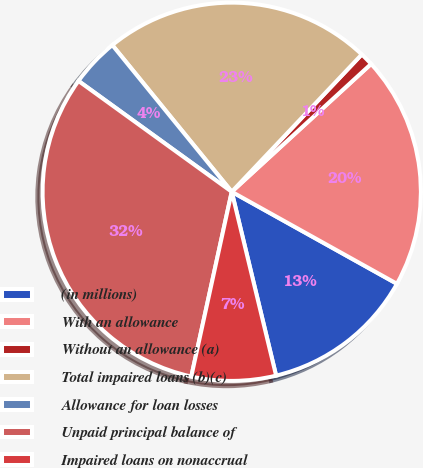<chart> <loc_0><loc_0><loc_500><loc_500><pie_chart><fcel>(in millions)<fcel>With an allowance<fcel>Without an allowance (a)<fcel>Total impaired loans (b)(c)<fcel>Allowance for loan losses<fcel>Unpaid principal balance of<fcel>Impaired loans on nonaccrual<nl><fcel>13.14%<fcel>19.9%<fcel>1.12%<fcel>22.94%<fcel>4.16%<fcel>31.53%<fcel>7.2%<nl></chart> 